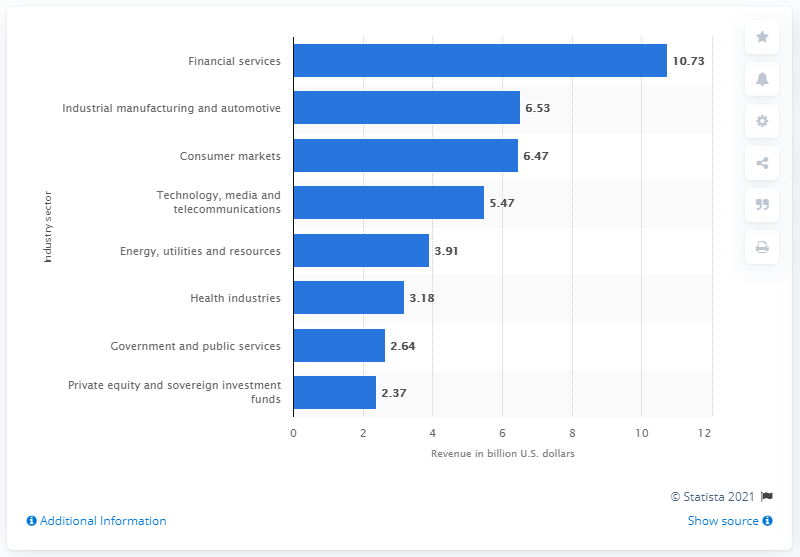Indicate a few pertinent items in this graphic. The financial services industry generated 10.73 million dollars for PricewaterhouseCoopers in 2018. PricewaterhouseCoopers generated more revenue from the financial services industry in 2018 than the next ranked industry sector by 10.73 dollars. 